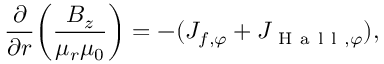<formula> <loc_0><loc_0><loc_500><loc_500>\frac { \partial } { \partial r } \left ( \frac { B _ { z } } { \mu _ { r } \mu _ { 0 } } \right ) = - ( J _ { f , \varphi } + J _ { H a l l , \varphi } ) ,</formula> 